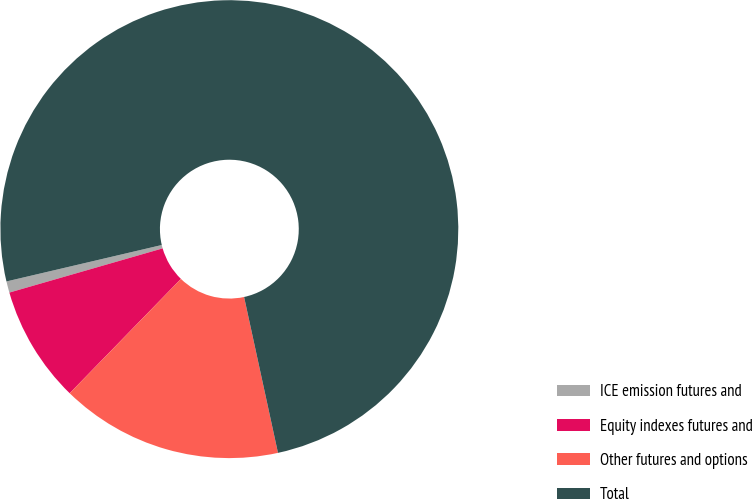<chart> <loc_0><loc_0><loc_500><loc_500><pie_chart><fcel>ICE emission futures and<fcel>Equity indexes futures and<fcel>Other futures and options<fcel>Total<nl><fcel>0.8%<fcel>8.25%<fcel>15.69%<fcel>75.26%<nl></chart> 